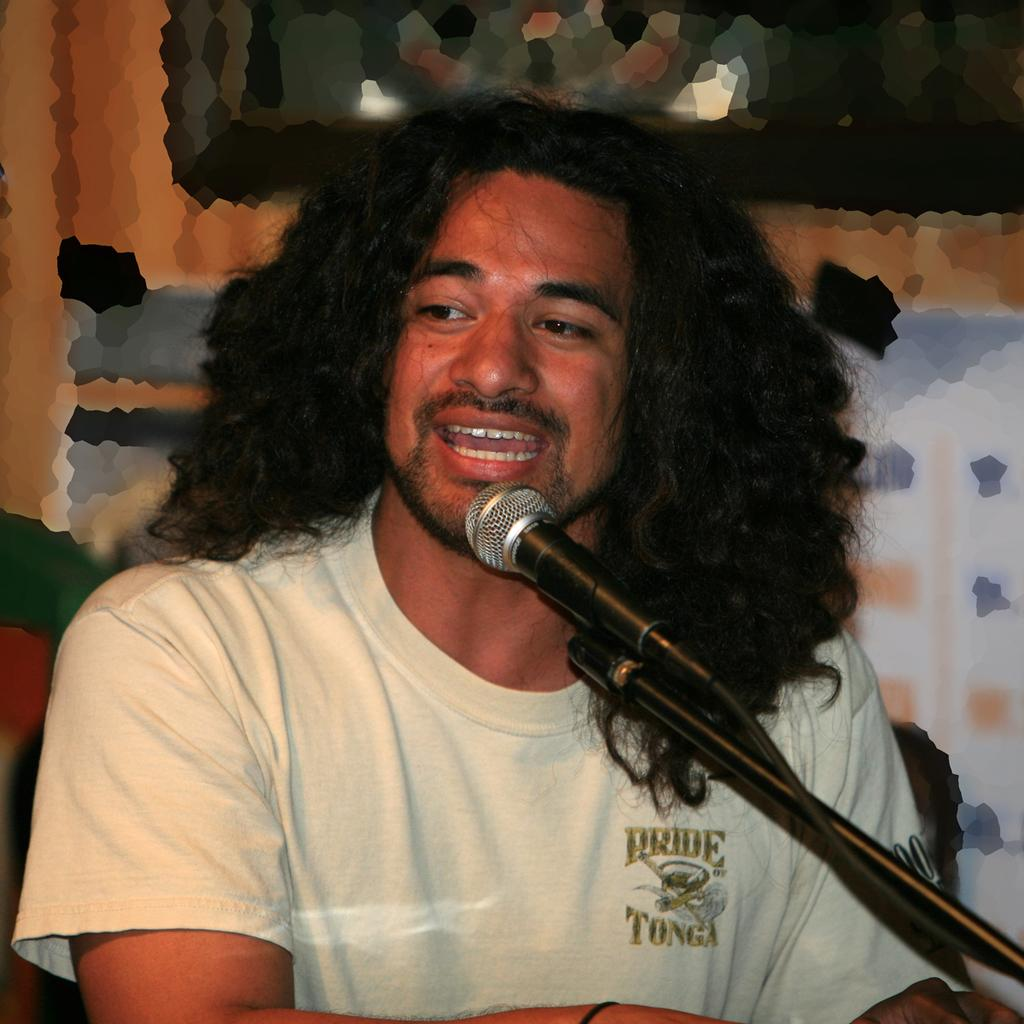Who is the main subject in the image? There is a man in the image. What is the man doing in the image? The man is speaking in the image. What object is the man using while speaking? The man is in front of a microphone. What is the man wearing in the image? The man is wearing a white T-shirt. Can you see any giants in the image? No, there are no giants present in the image. What type of pail is the man using to kick in the image? There is no pail or kicking activity in the image; the man is speaking in front of a microphone. 